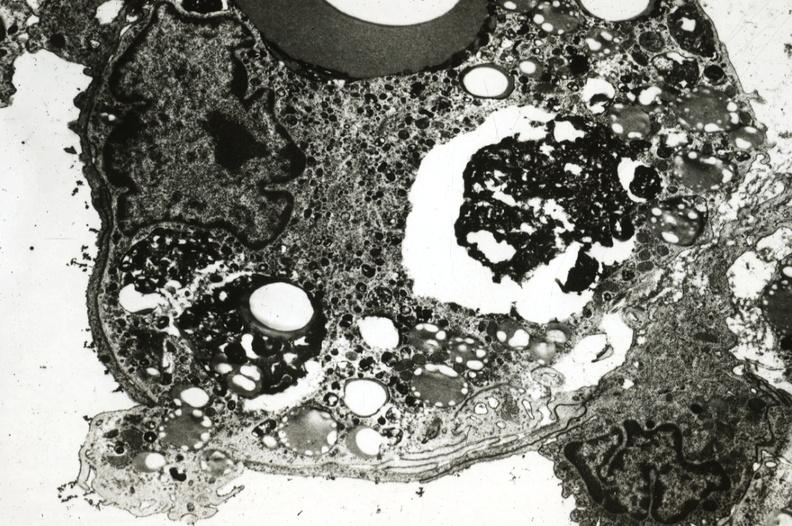does this image show rabbit foam cell with pseudopod extending through endothelium into lumen presumably exiting the aorta?
Answer the question using a single word or phrase. Yes 